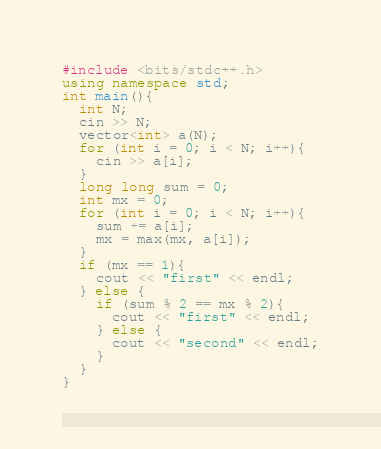Convert code to text. <code><loc_0><loc_0><loc_500><loc_500><_C++_>#include <bits/stdc++.h>
using namespace std;
int main(){
  int N;
  cin >> N;
  vector<int> a(N);
  for (int i = 0; i < N; i++){
    cin >> a[i];
  }
  long long sum = 0;
  int mx = 0;
  for (int i = 0; i < N; i++){
    sum += a[i];
    mx = max(mx, a[i]);
  }
  if (mx == 1){
    cout << "first" << endl;
  } else {
    if (sum % 2 == mx % 2){
      cout << "first" << endl;
    } else {
      cout << "second" << endl;
    }
  }
}</code> 